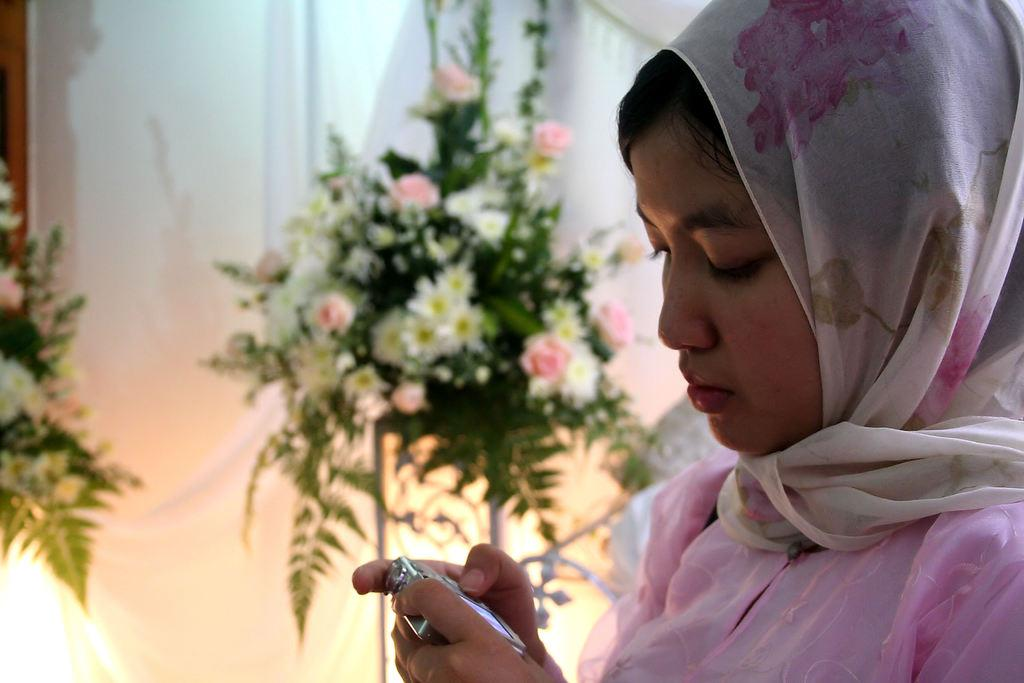Who is the main subject in the image? There is a woman in the image. What is the woman holding in her hands? The woman is holding a camera in her hands. What can be seen in the background of the image? There are flowers visible in the background of the image. What type of soap is the woman using to clean the table in the image? There is no table or soap present in the image; it features a woman holding a camera and flowers in the background. 